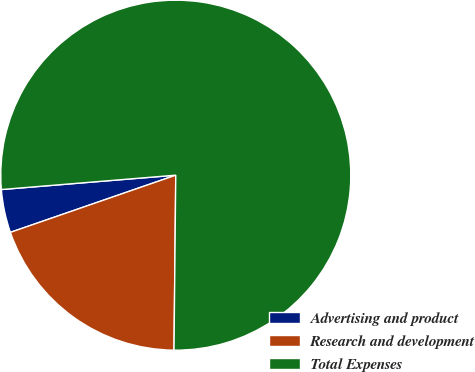Convert chart. <chart><loc_0><loc_0><loc_500><loc_500><pie_chart><fcel>Advertising and product<fcel>Research and development<fcel>Total Expenses<nl><fcel>3.99%<fcel>19.54%<fcel>76.47%<nl></chart> 